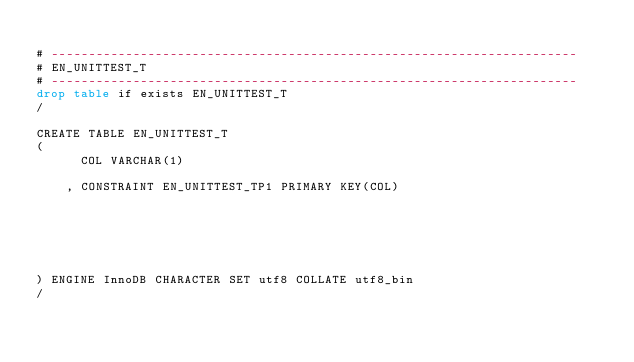Convert code to text. <code><loc_0><loc_0><loc_500><loc_500><_SQL_>
# -----------------------------------------------------------------------
# EN_UNITTEST_T
# -----------------------------------------------------------------------
drop table if exists EN_UNITTEST_T
/

CREATE TABLE EN_UNITTEST_T
(
      COL VARCHAR(1)
    
    , CONSTRAINT EN_UNITTEST_TP1 PRIMARY KEY(COL)






) ENGINE InnoDB CHARACTER SET utf8 COLLATE utf8_bin
/

</code> 